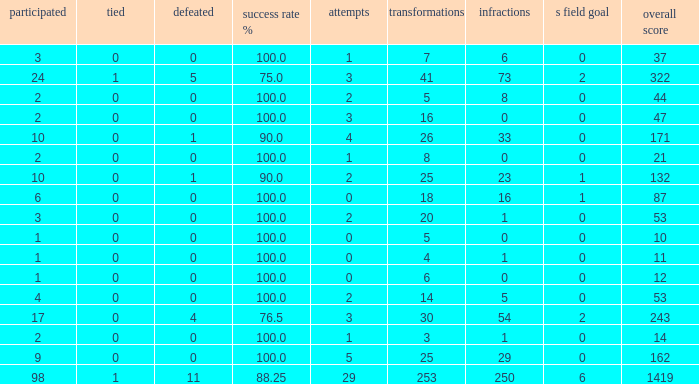What is the least number of penalties he got when his point total was over 1419 in more than 98 games? None. 